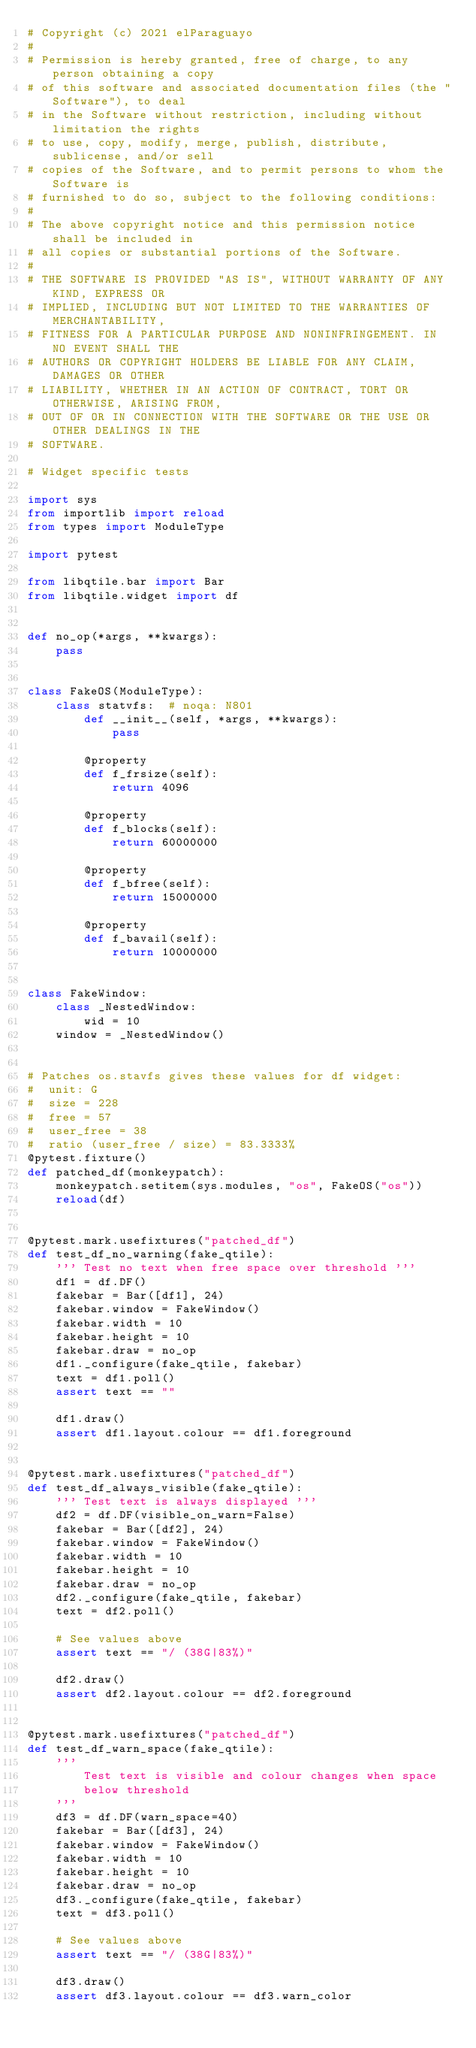<code> <loc_0><loc_0><loc_500><loc_500><_Python_># Copyright (c) 2021 elParaguayo
#
# Permission is hereby granted, free of charge, to any person obtaining a copy
# of this software and associated documentation files (the "Software"), to deal
# in the Software without restriction, including without limitation the rights
# to use, copy, modify, merge, publish, distribute, sublicense, and/or sell
# copies of the Software, and to permit persons to whom the Software is
# furnished to do so, subject to the following conditions:
#
# The above copyright notice and this permission notice shall be included in
# all copies or substantial portions of the Software.
#
# THE SOFTWARE IS PROVIDED "AS IS", WITHOUT WARRANTY OF ANY KIND, EXPRESS OR
# IMPLIED, INCLUDING BUT NOT LIMITED TO THE WARRANTIES OF MERCHANTABILITY,
# FITNESS FOR A PARTICULAR PURPOSE AND NONINFRINGEMENT. IN NO EVENT SHALL THE
# AUTHORS OR COPYRIGHT HOLDERS BE LIABLE FOR ANY CLAIM, DAMAGES OR OTHER
# LIABILITY, WHETHER IN AN ACTION OF CONTRACT, TORT OR OTHERWISE, ARISING FROM,
# OUT OF OR IN CONNECTION WITH THE SOFTWARE OR THE USE OR OTHER DEALINGS IN THE
# SOFTWARE.

# Widget specific tests

import sys
from importlib import reload
from types import ModuleType

import pytest

from libqtile.bar import Bar
from libqtile.widget import df


def no_op(*args, **kwargs):
    pass


class FakeOS(ModuleType):
    class statvfs:  # noqa: N801
        def __init__(self, *args, **kwargs):
            pass

        @property
        def f_frsize(self):
            return 4096

        @property
        def f_blocks(self):
            return 60000000

        @property
        def f_bfree(self):
            return 15000000

        @property
        def f_bavail(self):
            return 10000000


class FakeWindow:
    class _NestedWindow:
        wid = 10
    window = _NestedWindow()


# Patches os.stavfs gives these values for df widget:
#  unit: G
#  size = 228
#  free = 57
#  user_free = 38
#  ratio (user_free / size) = 83.3333%
@pytest.fixture()
def patched_df(monkeypatch):
    monkeypatch.setitem(sys.modules, "os", FakeOS("os"))
    reload(df)


@pytest.mark.usefixtures("patched_df")
def test_df_no_warning(fake_qtile):
    ''' Test no text when free space over threshold '''
    df1 = df.DF()
    fakebar = Bar([df1], 24)
    fakebar.window = FakeWindow()
    fakebar.width = 10
    fakebar.height = 10
    fakebar.draw = no_op
    df1._configure(fake_qtile, fakebar)
    text = df1.poll()
    assert text == ""

    df1.draw()
    assert df1.layout.colour == df1.foreground


@pytest.mark.usefixtures("patched_df")
def test_df_always_visible(fake_qtile):
    ''' Test text is always displayed '''
    df2 = df.DF(visible_on_warn=False)
    fakebar = Bar([df2], 24)
    fakebar.window = FakeWindow()
    fakebar.width = 10
    fakebar.height = 10
    fakebar.draw = no_op
    df2._configure(fake_qtile, fakebar)
    text = df2.poll()

    # See values above
    assert text == "/ (38G|83%)"

    df2.draw()
    assert df2.layout.colour == df2.foreground


@pytest.mark.usefixtures("patched_df")
def test_df_warn_space(fake_qtile):
    '''
        Test text is visible and colour changes when space
        below threshold
    '''
    df3 = df.DF(warn_space=40)
    fakebar = Bar([df3], 24)
    fakebar.window = FakeWindow()
    fakebar.width = 10
    fakebar.height = 10
    fakebar.draw = no_op
    df3._configure(fake_qtile, fakebar)
    text = df3.poll()

    # See values above
    assert text == "/ (38G|83%)"

    df3.draw()
    assert df3.layout.colour == df3.warn_color
</code> 